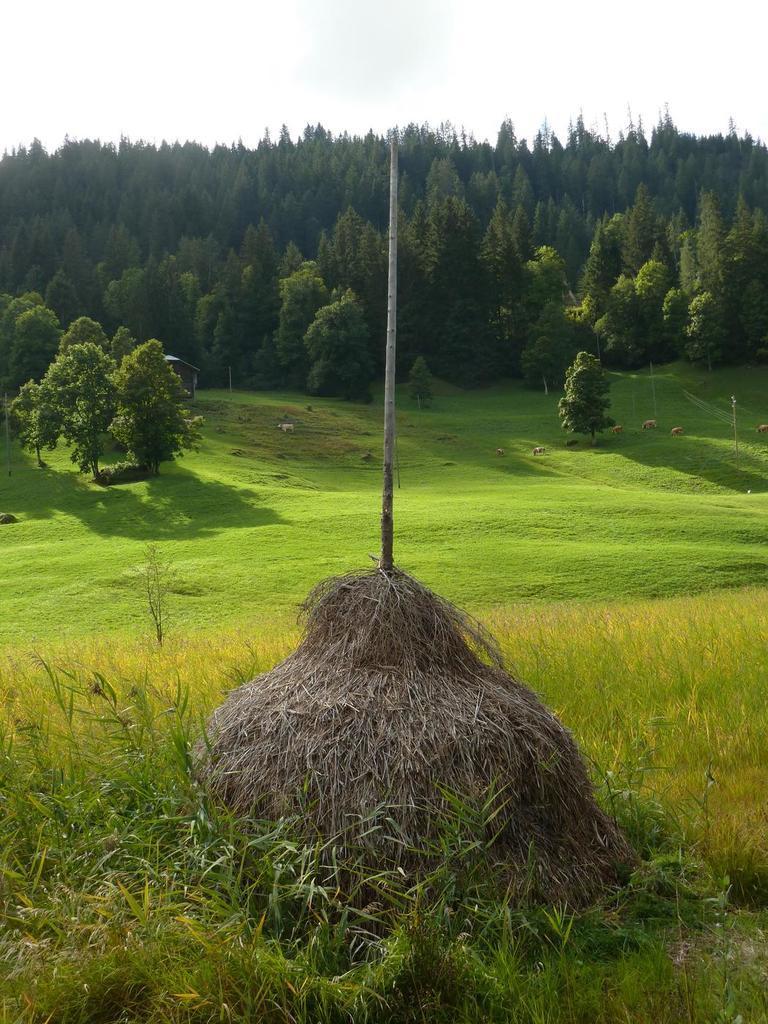Could you give a brief overview of what you see in this image? The picture is clicked in a field. In the foreground of the picture there are plants, grass, dry grass and a pole. In the center of the picture there are trees and grass. In the background there are trees. Sky is sunny. 